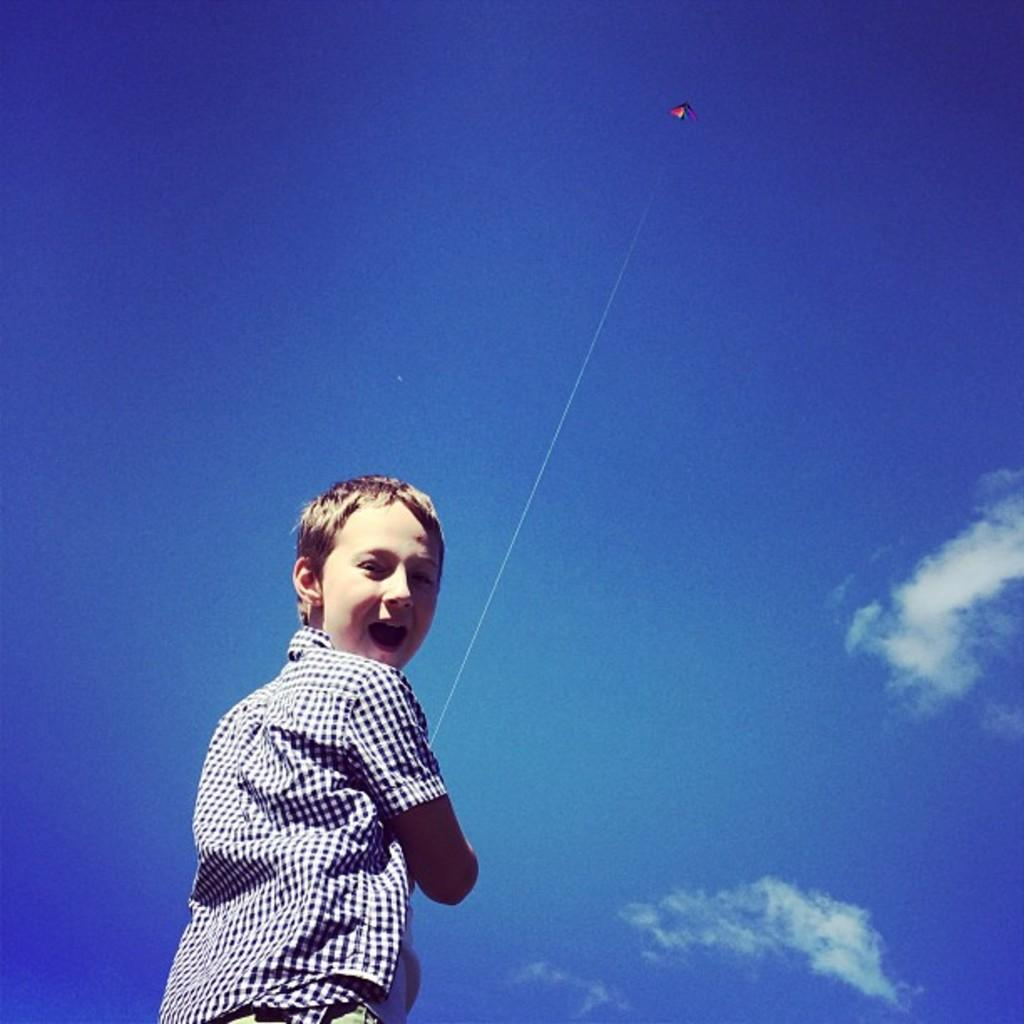What is the main subject of the image? The main subject of the image is a kid. What is the kid doing in the image? The kid is flying a kite. What is the color of the sky in the image? The sky is blue in the image. Why is the metal object in the image crying? There is no metal object present in the image, and therefore it cannot be crying. 